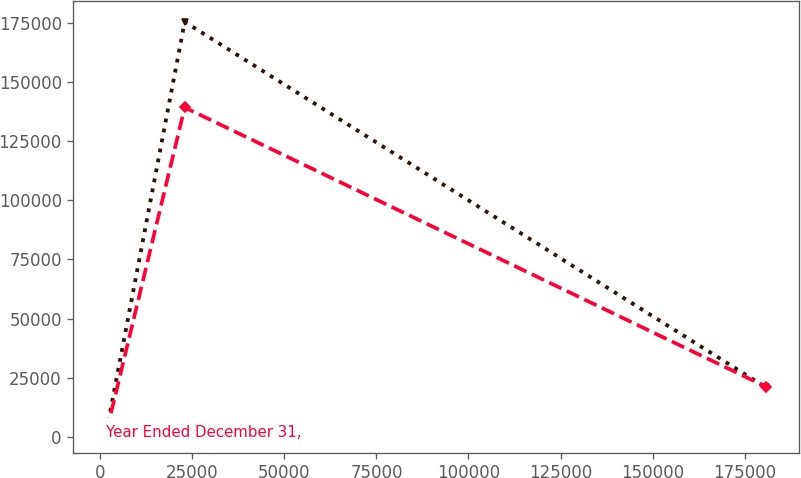Convert chart to OTSL. <chart><loc_0><loc_0><loc_500><loc_500><line_chart><ecel><fcel>Unnamed: 1<fcel>Year Ended December 31,<nl><fcel>1656.86<fcel>2319.66<fcel>2112.16<nl><fcel>22923.5<fcel>175300<fcel>139159<nl><fcel>180744<fcel>21035.8<fcel>21337.8<nl></chart> 